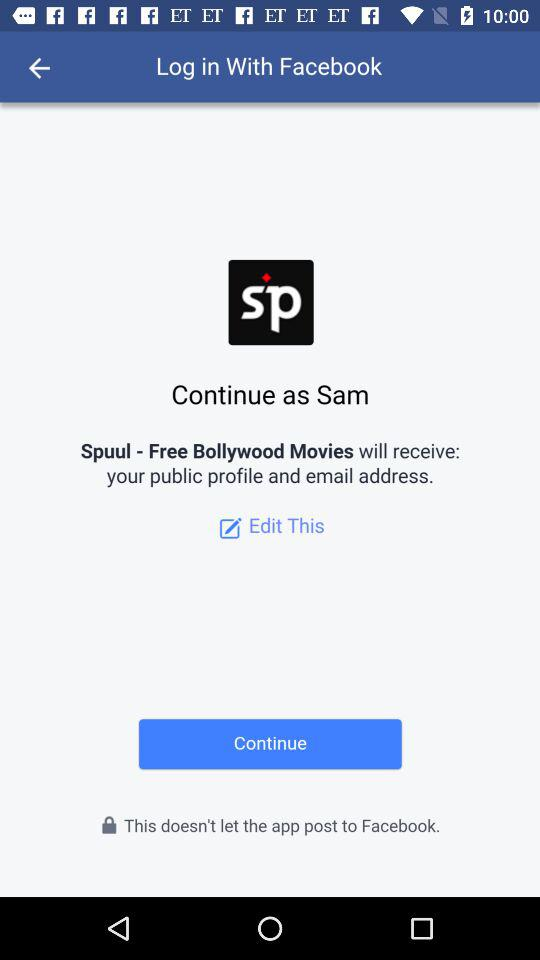Who will receive the public figure and email address? The public figure and email address will be received by "Spuul - Free Bollywood Movies". 